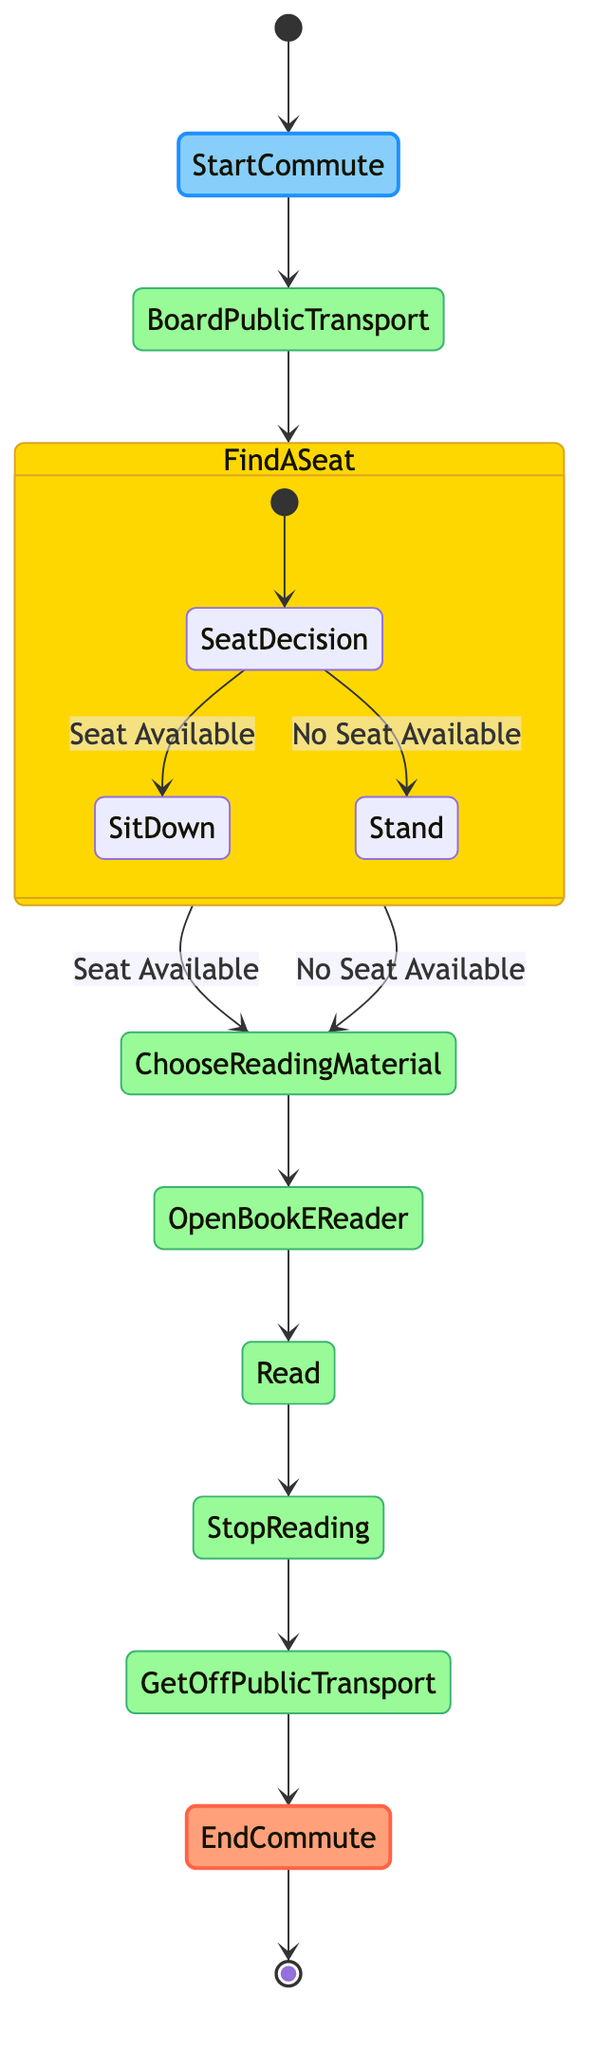What is the first activity in the diagram? The diagram starts with the "Start Commute" node, which is the initial point of the activity flow.
Answer: Start Commute How many decision branches are present in the "Find a Seat" activity? The "Find a Seat" activity has two branches: one for "Seat Available" and another for "No Seat Available," which leads to different actions.
Answer: 2 Which activity follows "Open Book/E-Reader"? After completing the "Open Book/E-Reader" action, the next activity in the flow is "Read."
Answer: Read What happens if a seat is available according to the diagram? If a seat is available, the flow proceeds from "Find a Seat" to "Choose Reading Material," indicating that reading material selection occurs regardless of seating status.
Answer: Choose Reading Material What is the last action before ending the commute? The last action before reaching the "End Commute" is "Get Off Public Transport," marking the transition from transportation to finishing the commute.
Answer: Get Off Public Transport If a person stands, which action follows according to the diagram? Whether a person stands or finds a seat, they proceed to the "Choose Reading Material," indicating that the choice of what to read remains unaffected by the seating situation.
Answer: Choose Reading Material How do both branches of "Find a Seat" lead to the next activity? Both branches under "Find a Seat"—"Seat Available" and "No Seat Available"—directly lead to "Choose Reading Material," indicating that the choice of reading material follows regardless of seating status.
Answer: Choose Reading Material How many total activities are there in the diagram? The diagram includes a total of eight distinct activities from start to end of the commute journey.
Answer: 8 